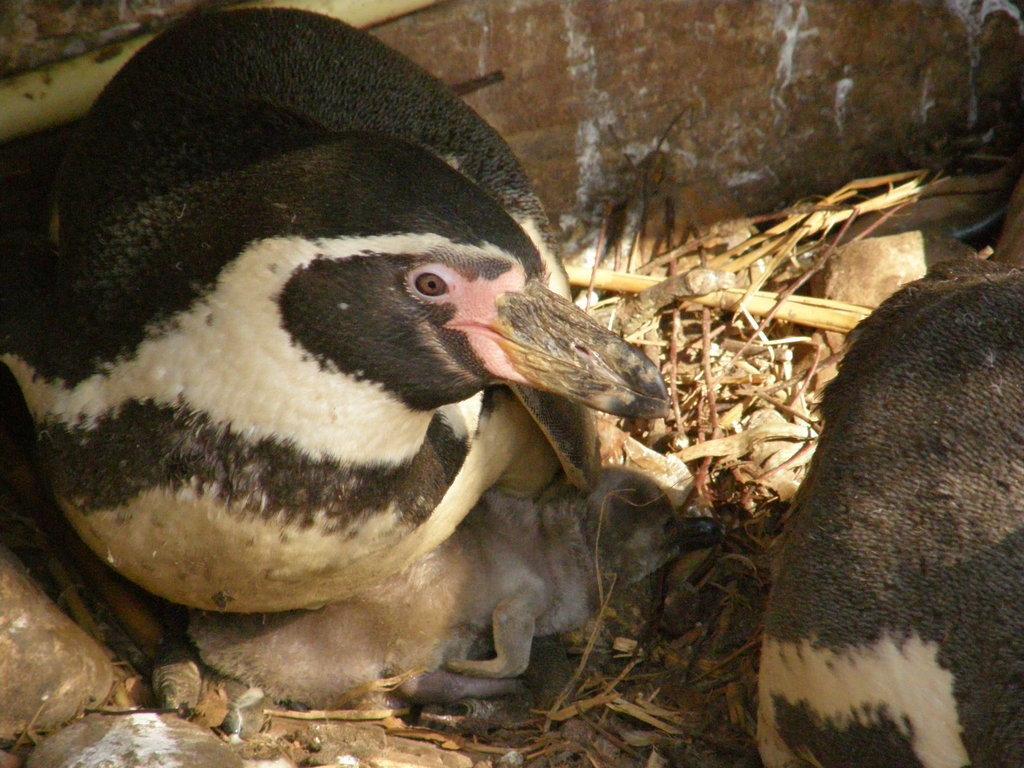Can you describe this image briefly? In this picture we can see birds, dried grass and stones. In the background of the image we can see wall. 